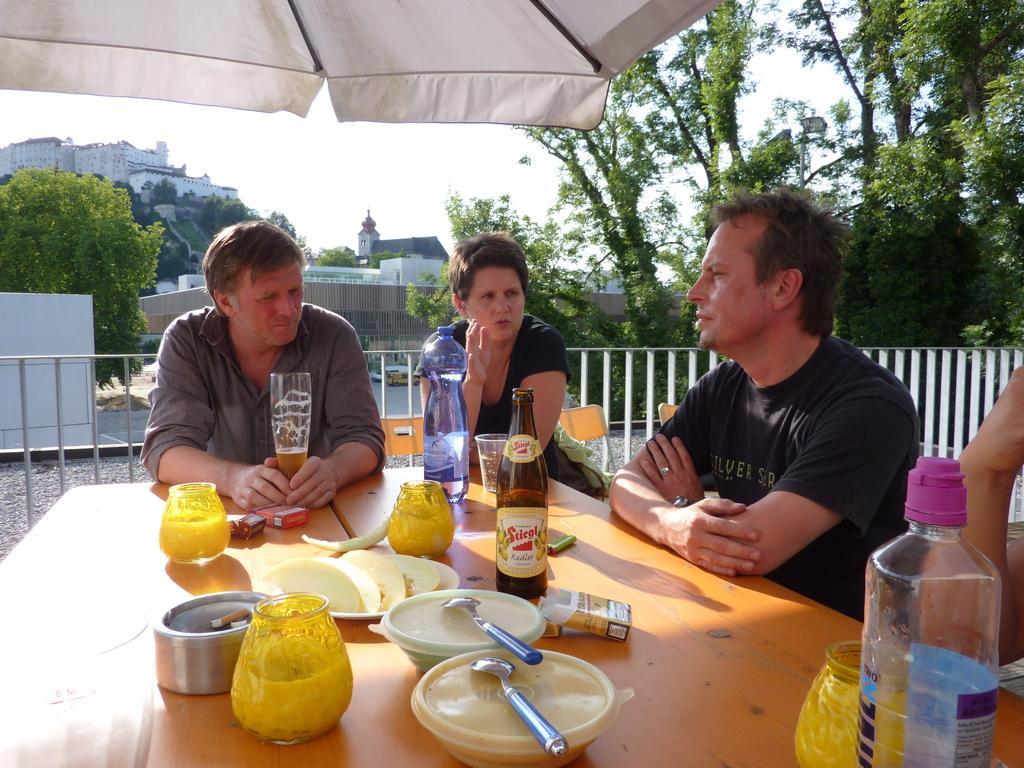How would you summarize this image in a sentence or two? There are four people sitting around the table under the tent. The women with black t-shirt is talking and the men beside the women are listening. There are plates, boxes, spoons, astray on the table. At the background there is a road , there is a tree at the right of the image, there is a building at the back, at the top there is a sky and city seems very sunny. 